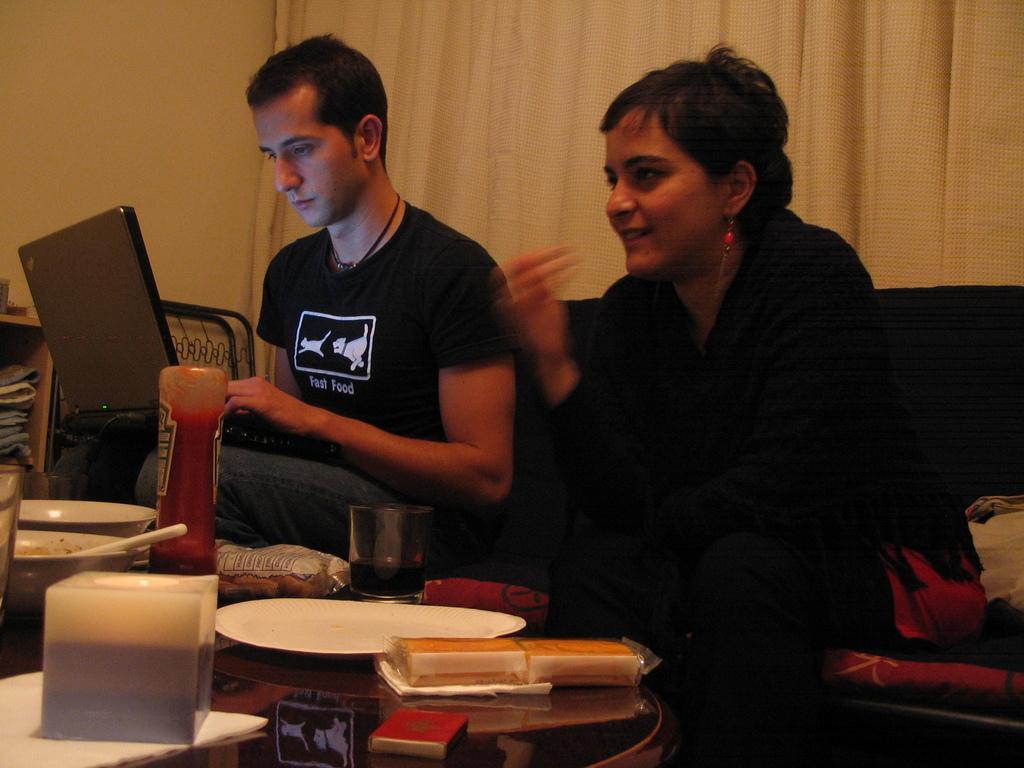Describe this image in one or two sentences. I can see in this image a man and woman are sitting on a couch in front of a table. The man is operating a laptop and on the table we have some objects on it. In the background I can see a curtain and a wall. 